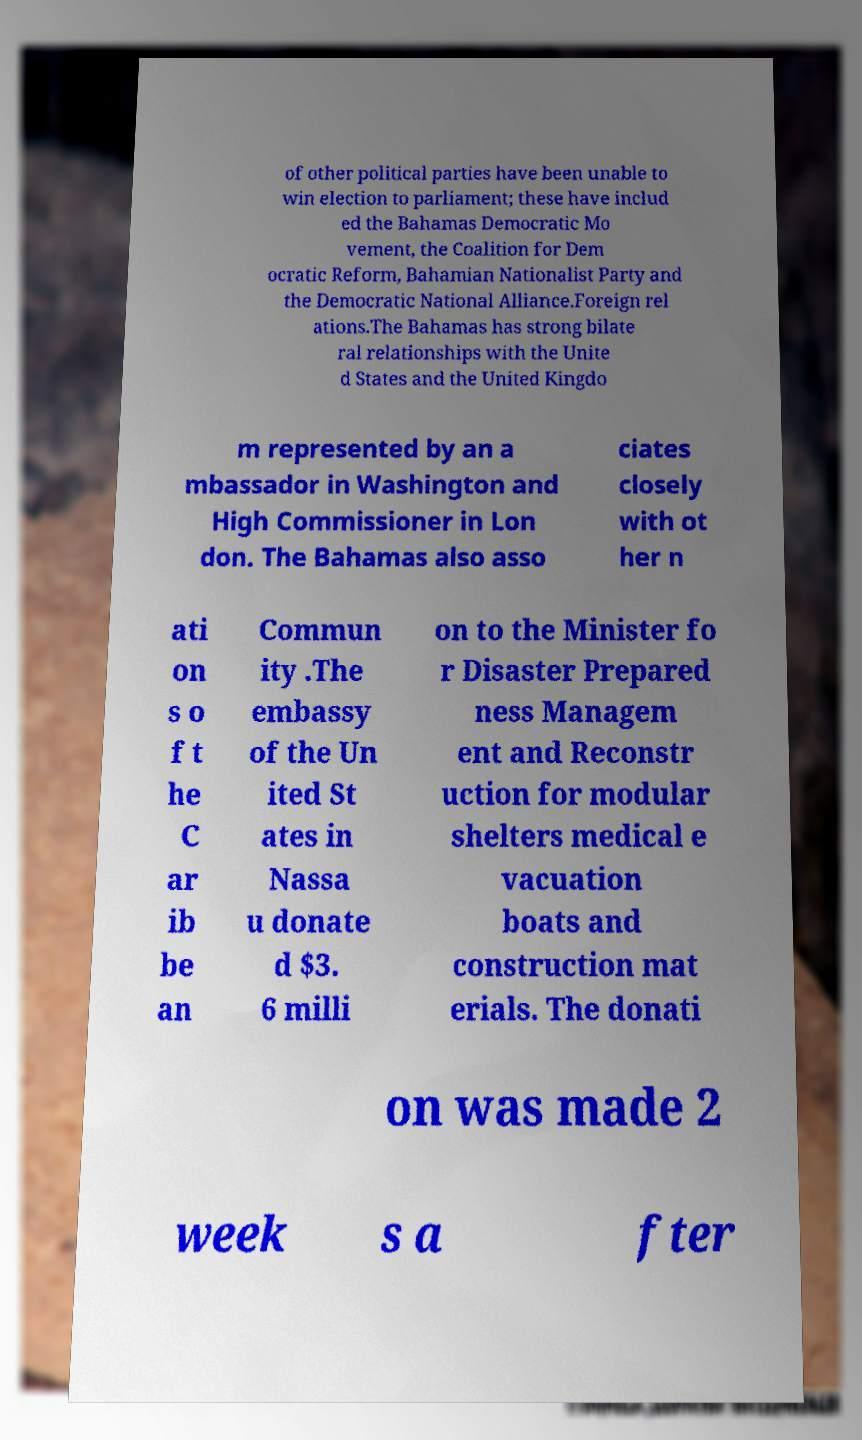There's text embedded in this image that I need extracted. Can you transcribe it verbatim? of other political parties have been unable to win election to parliament; these have includ ed the Bahamas Democratic Mo vement, the Coalition for Dem ocratic Reform, Bahamian Nationalist Party and the Democratic National Alliance.Foreign rel ations.The Bahamas has strong bilate ral relationships with the Unite d States and the United Kingdo m represented by an a mbassador in Washington and High Commissioner in Lon don. The Bahamas also asso ciates closely with ot her n ati on s o f t he C ar ib be an Commun ity .The embassy of the Un ited St ates in Nassa u donate d $3. 6 milli on to the Minister fo r Disaster Prepared ness Managem ent and Reconstr uction for modular shelters medical e vacuation boats and construction mat erials. The donati on was made 2 week s a fter 